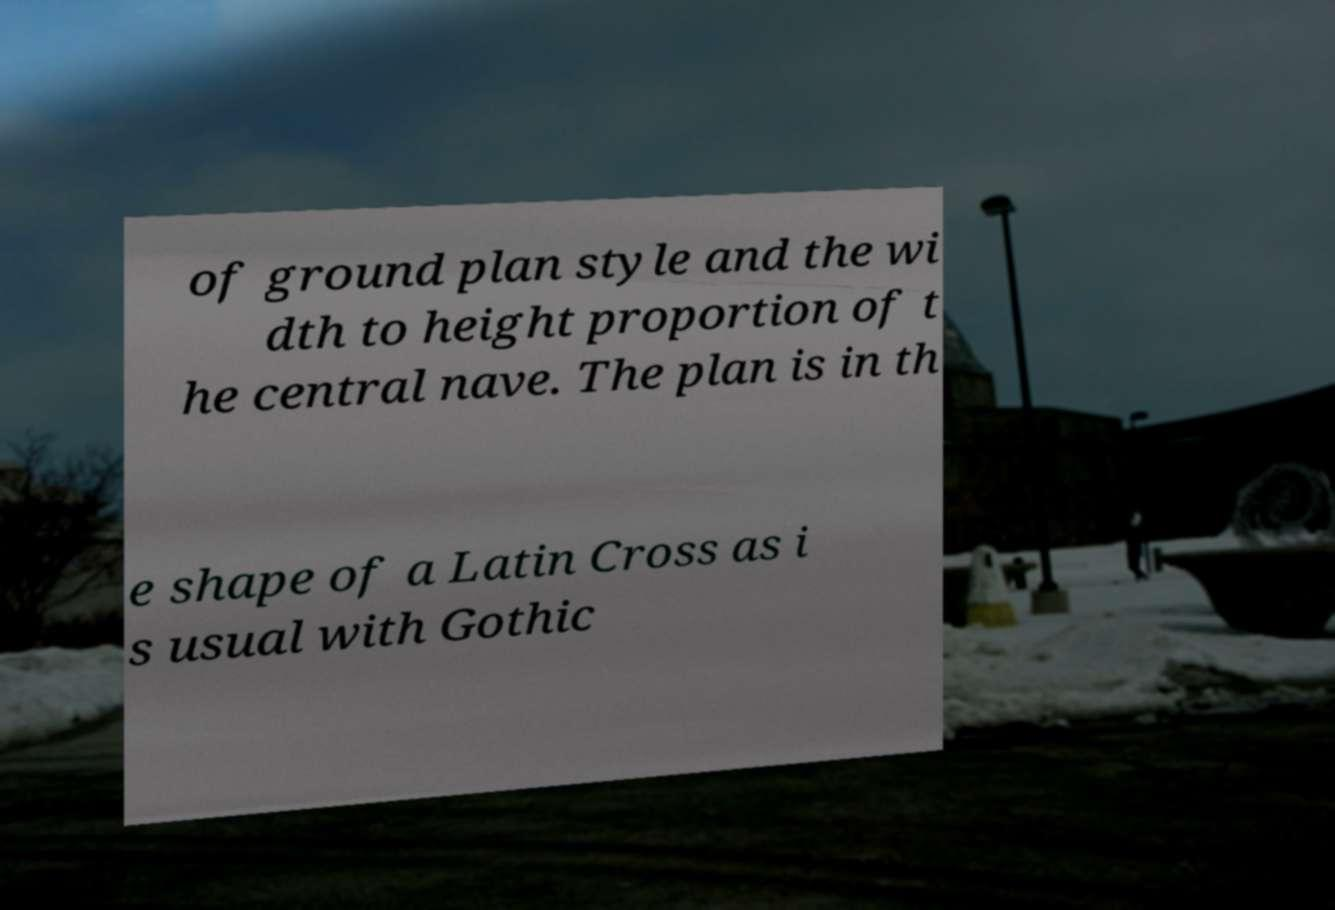What messages or text are displayed in this image? I need them in a readable, typed format. of ground plan style and the wi dth to height proportion of t he central nave. The plan is in th e shape of a Latin Cross as i s usual with Gothic 